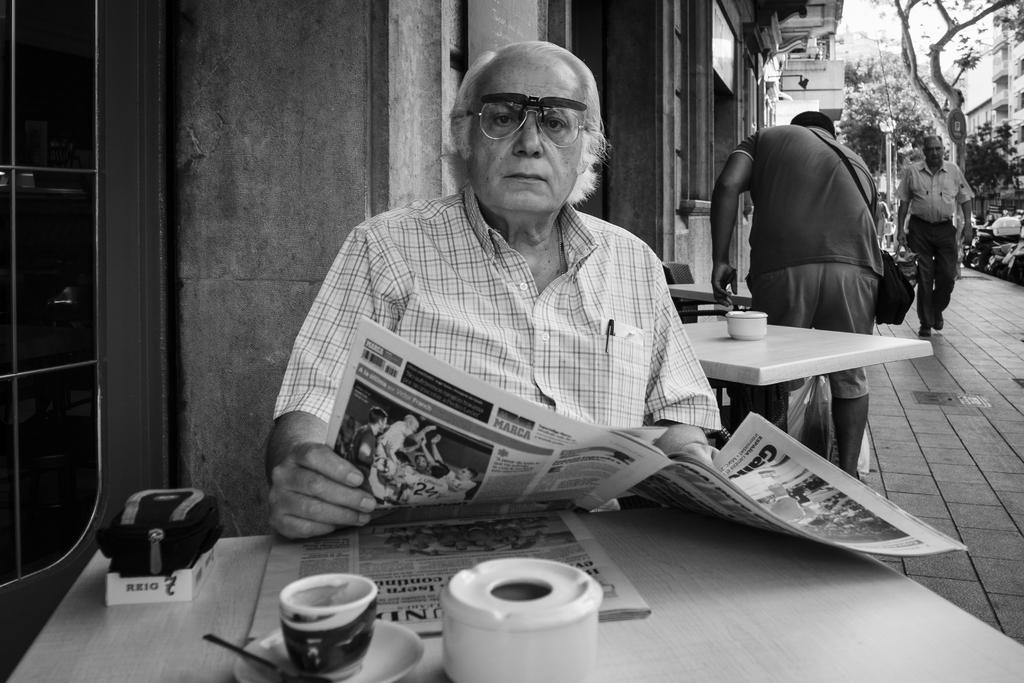Who is the main subject in the image? There is an old man in the image. What is the old man doing in the image? The old man is sitting in front of a table and holding a newspaper. Where is the image set? The image is set on a street. What can be seen in the background of the image? There are buildings and trees in the background. What is the rate of the railway in the image? There is no railway present in the image, so it is not possible to determine the rate. 